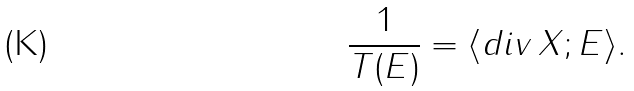<formula> <loc_0><loc_0><loc_500><loc_500>\frac { 1 } { T ( E ) } = \langle d i v \, X ; E \rangle .</formula> 